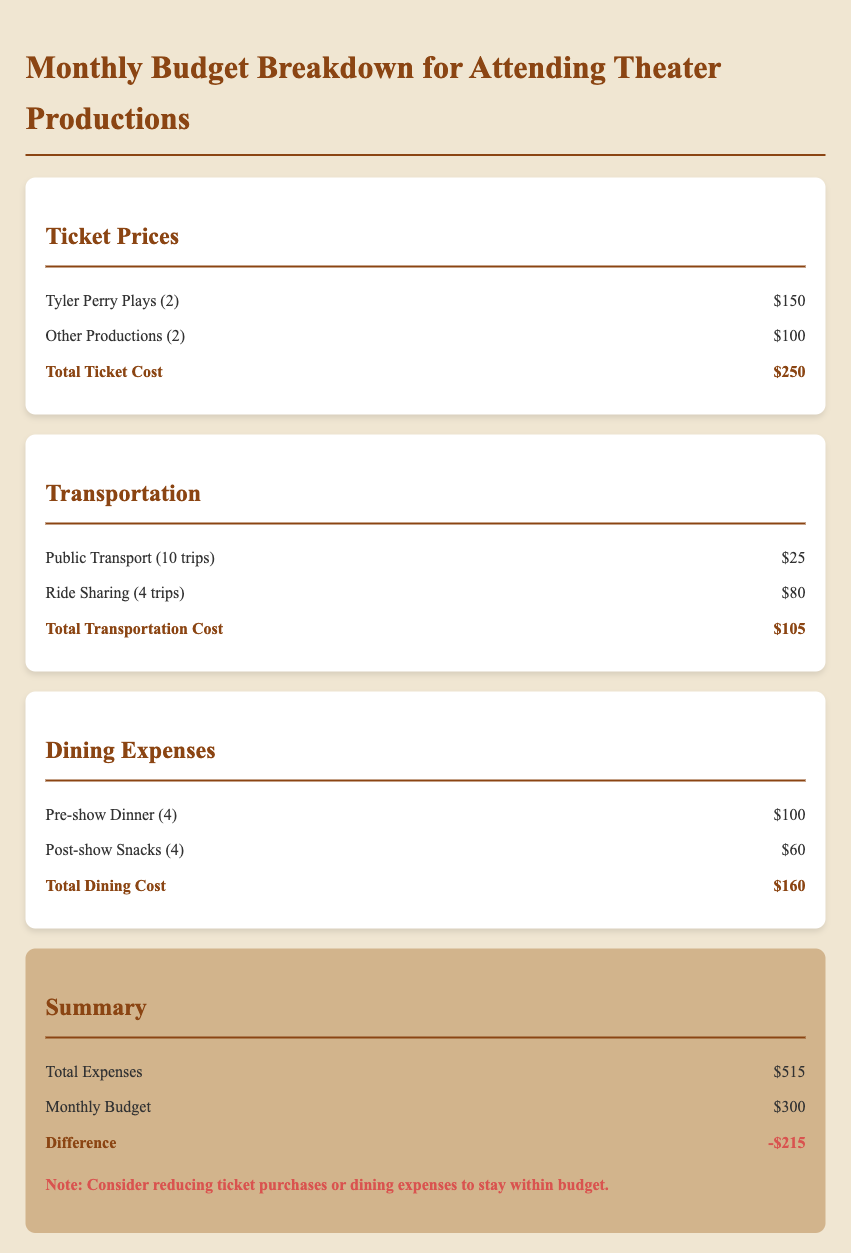What is the total ticket cost for Tyler Perry plays? The ticket cost for Tyler Perry plays is specified as $150 in the document.
Answer: $150 How many pre-show dinners are included in the dining expenses? The document states there are 4 pre-show dinners included in the dining expenses.
Answer: 4 What is the total transportation cost? The document lists the total transportation cost as $105.
Answer: $105 What is the difference between total expenses and monthly budget? The document indicates the difference is -$215, indicating expenses exceed the budget.
Answer: -$215 How many ride-sharing trips are included in the transportation expenses? The document mentions there are 4 ride-sharing trips included in the transportation expenses.
Answer: 4 What is the total dining cost? The total dining cost, as detailed in the document, is $160.
Answer: $160 What is the cost for other productions? The document specifies the cost for other productions as $100.
Answer: $100 How many public transport trips were accounted for in the budget? The document states there were 10 public transport trips accounted for.
Answer: 10 